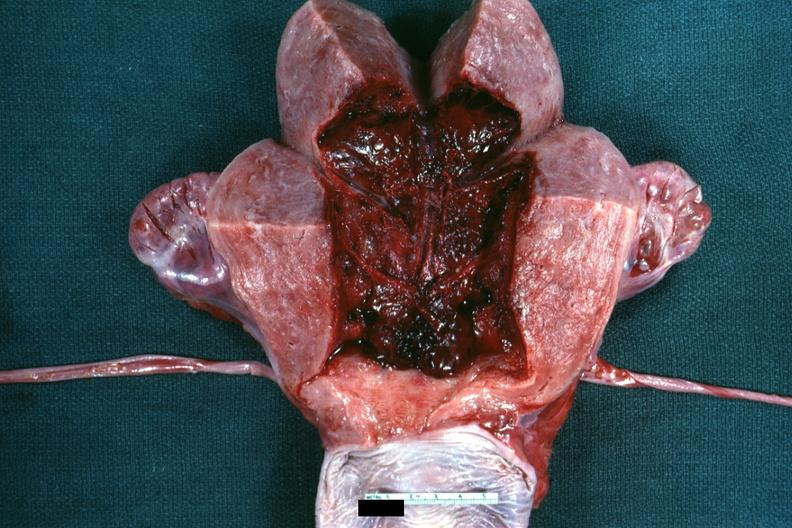s postpartum present?
Answer the question using a single word or phrase. Yes 